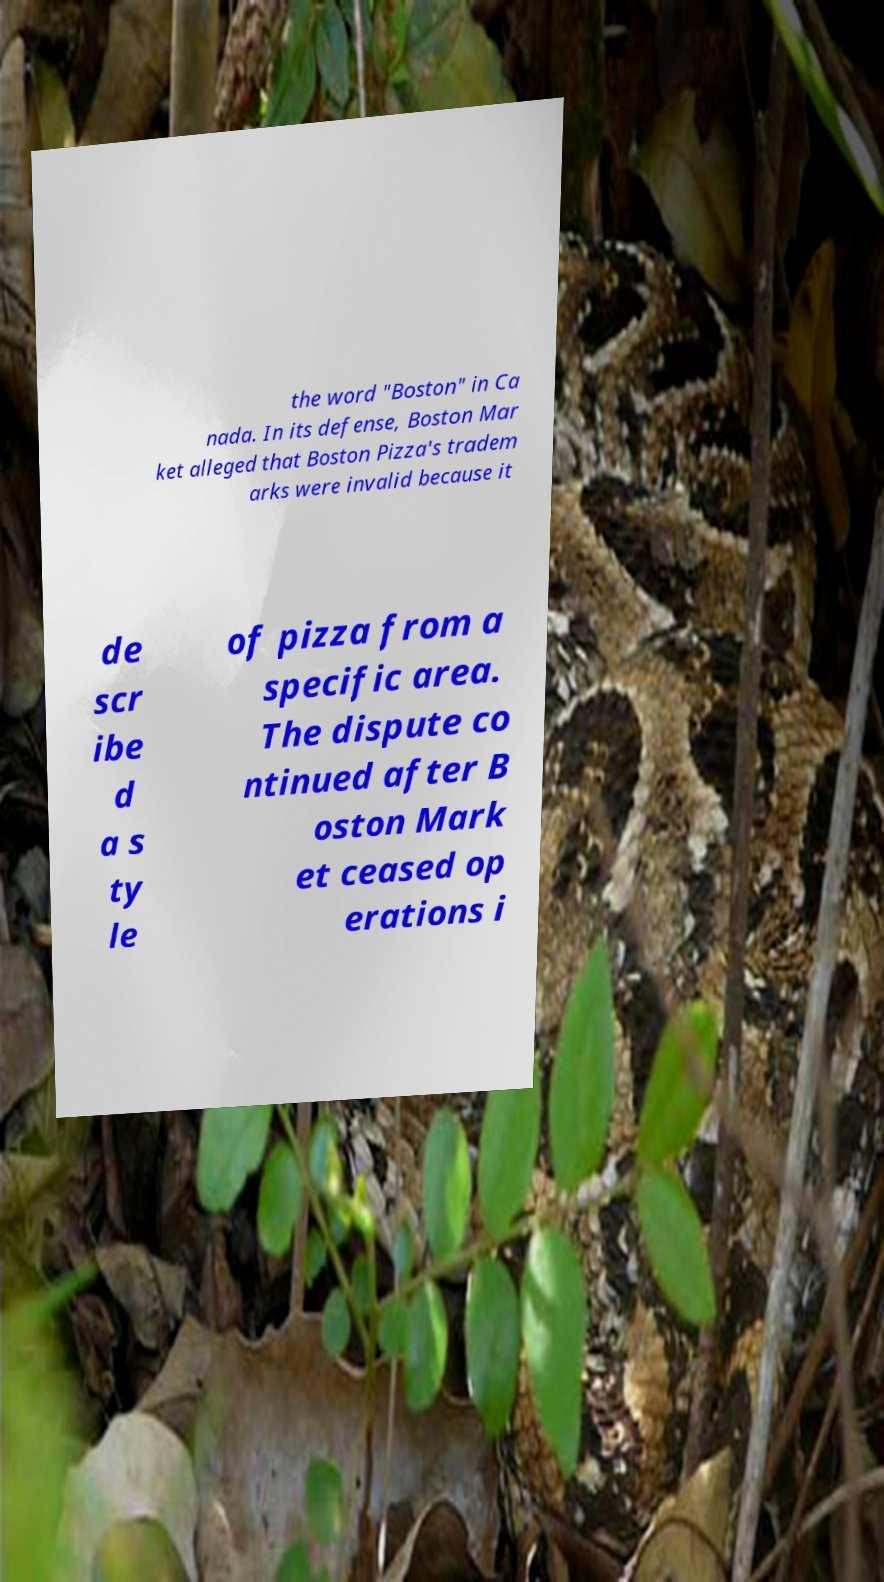Could you extract and type out the text from this image? the word "Boston" in Ca nada. In its defense, Boston Mar ket alleged that Boston Pizza's tradem arks were invalid because it de scr ibe d a s ty le of pizza from a specific area. The dispute co ntinued after B oston Mark et ceased op erations i 